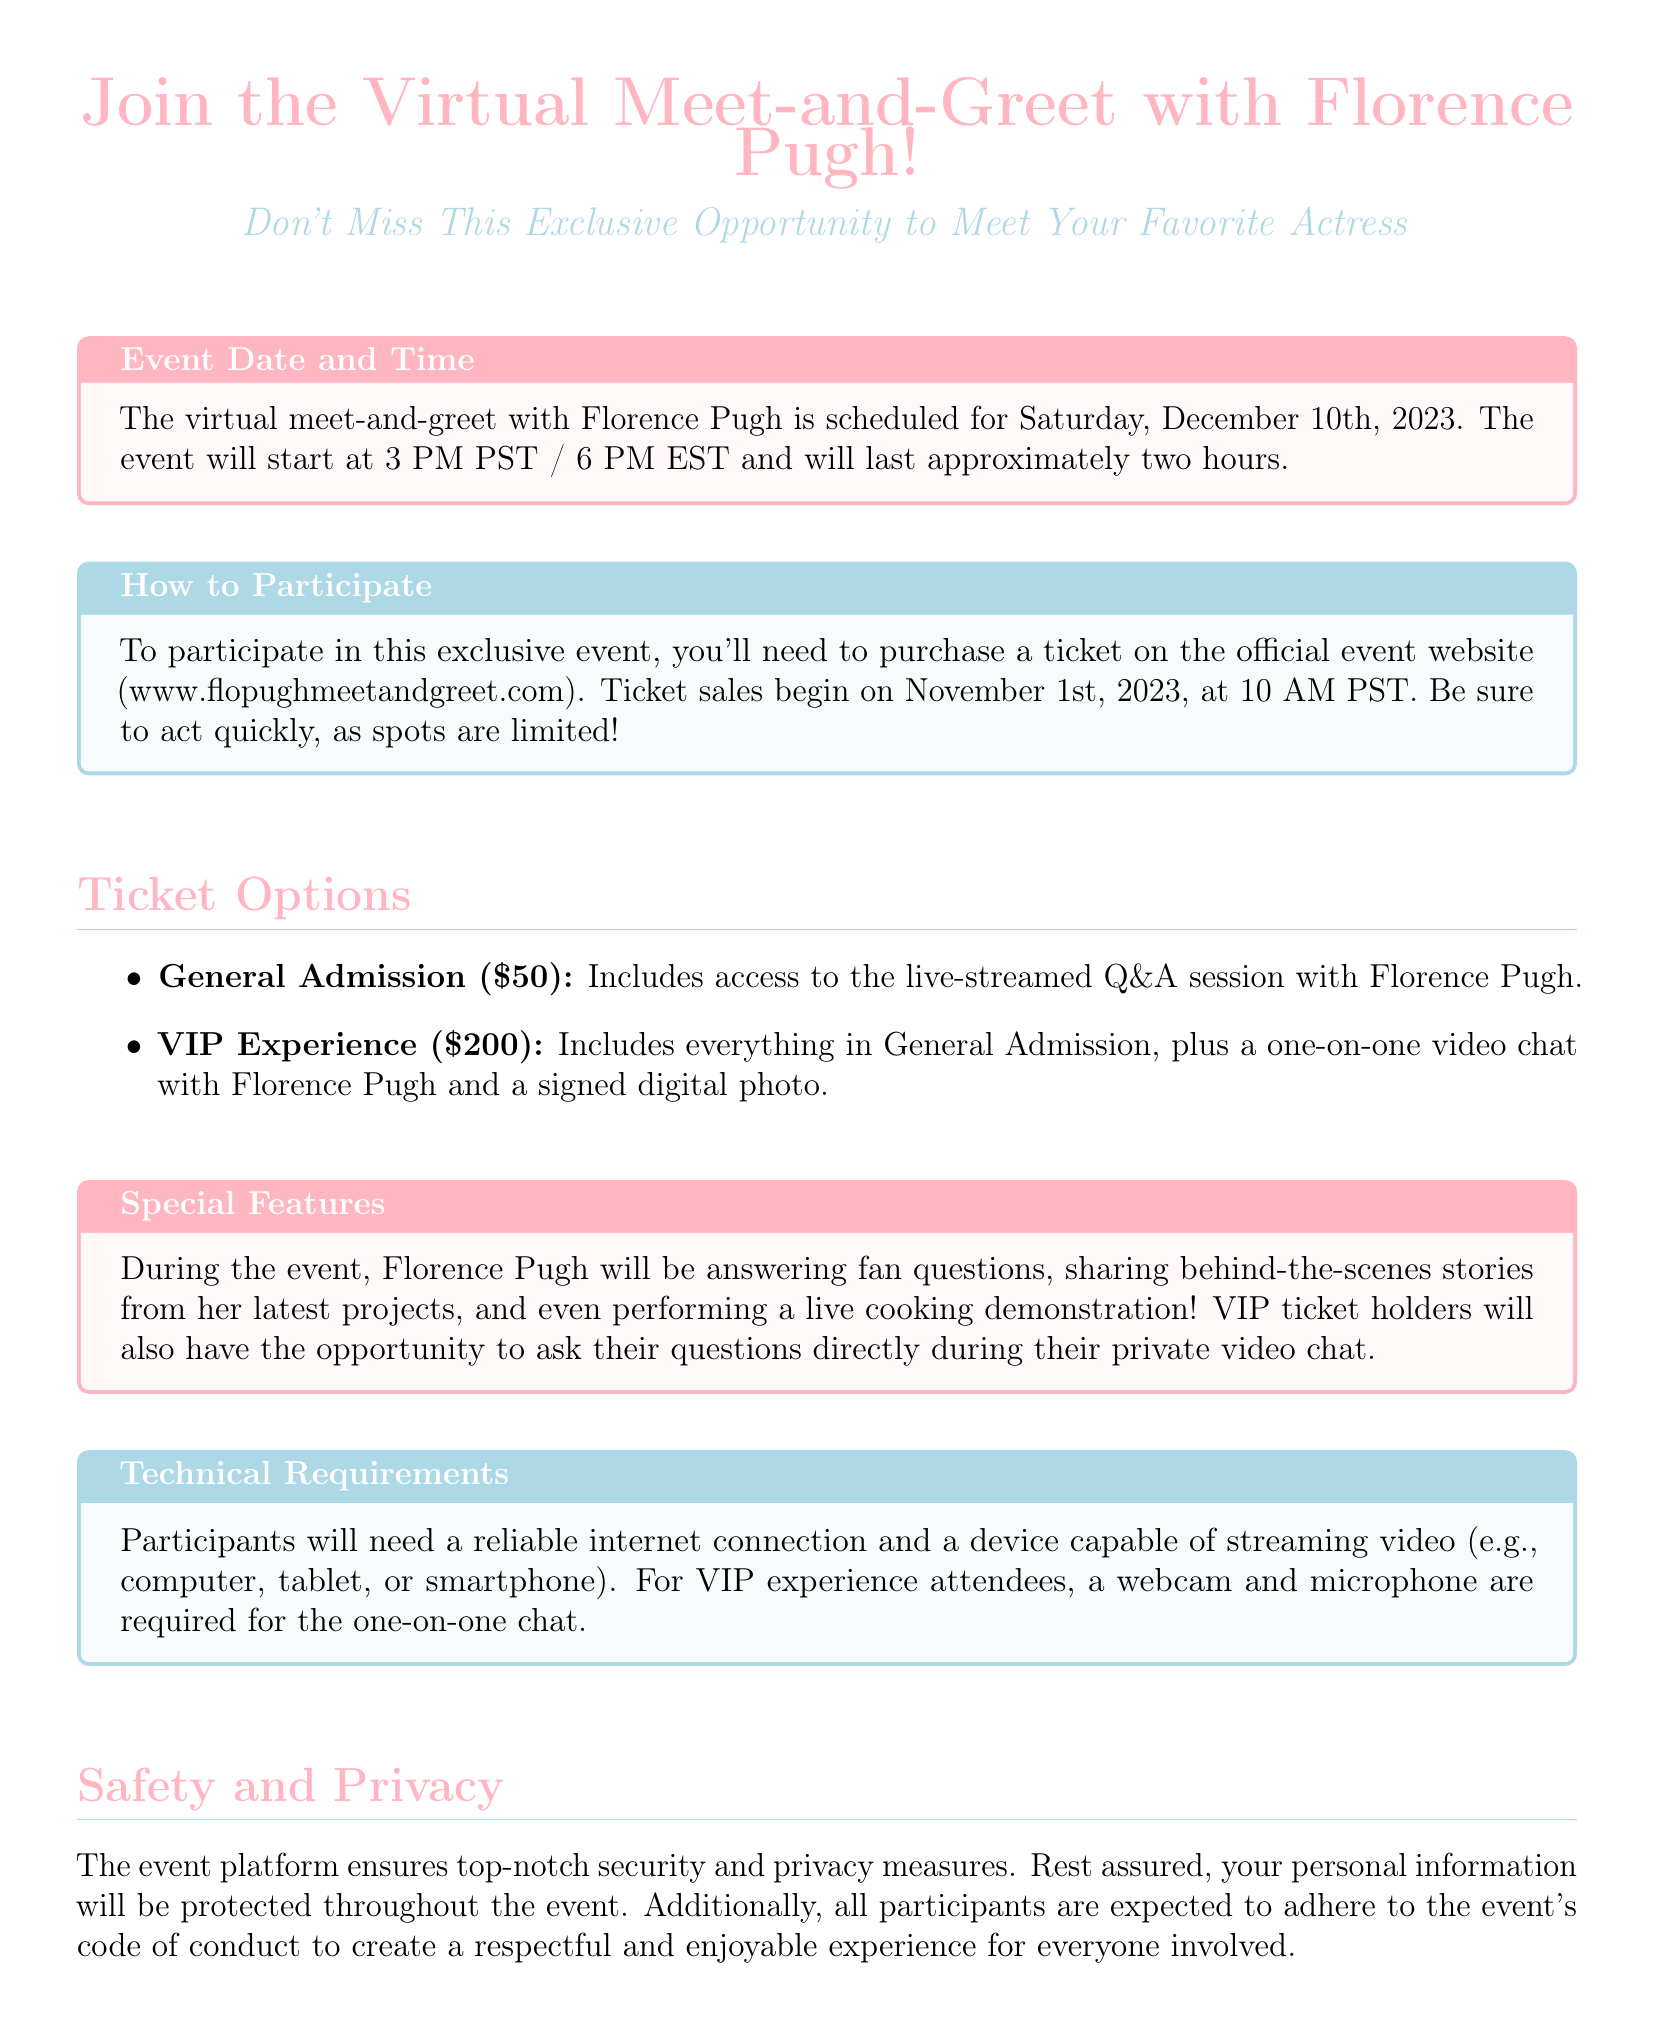What is the event date? The event date is clearly stated in the document as Saturday, December 10th, 2023.
Answer: December 10th, 2023 What is the duration of the event? The document mentions that the event will last approximately two hours.
Answer: two hours What is the URL for ticket purchases? The official website for ticket purchases is provided in the document as www.flopughmeetandgreet.com.
Answer: www.flopughmeetandgreet.com What are the two types of tickets available? The document lists General Admission and VIP Experience as the two ticket types.
Answer: General Admission and VIP Experience How much does the VIP Experience cost? The document specifies that the VIP Experience ticket costs $200.
Answer: $200 What special feature will be available for VIP ticket holders? The document mentions that VIP ticket holders will have a one-on-one video chat with Florence Pugh.
Answer: one-on-one video chat When do ticket sales begin? According to the document, ticket sales will begin on November 1st, 2023, at 10 AM PST.
Answer: November 1st, 2023 What is required for the one-on-one chat? The document states that a webcam and microphone are required for VIP experience attendees during the one-on-one chat.
Answer: webcam and microphone What contact information is provided for inquiries? The document includes support@flopughmeetandgreet.com as the contact email for inquiries.
Answer: support@flopughmeetandgreet.com 